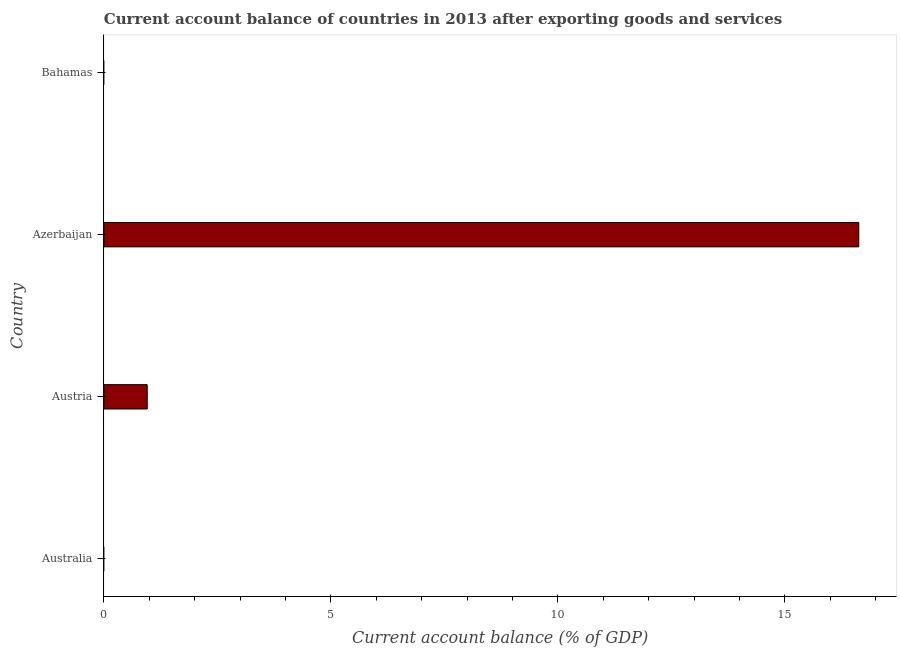What is the title of the graph?
Give a very brief answer. Current account balance of countries in 2013 after exporting goods and services. What is the label or title of the X-axis?
Make the answer very short. Current account balance (% of GDP). What is the label or title of the Y-axis?
Offer a terse response. Country. Across all countries, what is the maximum current account balance?
Your response must be concise. 16.63. In which country was the current account balance maximum?
Offer a terse response. Azerbaijan. What is the sum of the current account balance?
Offer a very short reply. 17.58. What is the difference between the current account balance in Austria and Azerbaijan?
Offer a very short reply. -15.67. What is the average current account balance per country?
Your answer should be very brief. 4.4. What is the median current account balance?
Offer a very short reply. 0.48. In how many countries, is the current account balance greater than 13 %?
Offer a terse response. 1. Is the current account balance in Austria less than that in Azerbaijan?
Keep it short and to the point. Yes. Is the difference between the current account balance in Austria and Azerbaijan greater than the difference between any two countries?
Provide a succinct answer. No. What is the difference between the highest and the lowest current account balance?
Your answer should be very brief. 16.63. In how many countries, is the current account balance greater than the average current account balance taken over all countries?
Provide a short and direct response. 1. How many bars are there?
Your response must be concise. 2. Are all the bars in the graph horizontal?
Provide a short and direct response. Yes. What is the difference between two consecutive major ticks on the X-axis?
Provide a succinct answer. 5. Are the values on the major ticks of X-axis written in scientific E-notation?
Provide a short and direct response. No. What is the Current account balance (% of GDP) of Australia?
Your response must be concise. 0. What is the Current account balance (% of GDP) in Austria?
Offer a terse response. 0.95. What is the Current account balance (% of GDP) of Azerbaijan?
Give a very brief answer. 16.63. What is the Current account balance (% of GDP) of Bahamas?
Your response must be concise. 0. What is the difference between the Current account balance (% of GDP) in Austria and Azerbaijan?
Provide a short and direct response. -15.67. What is the ratio of the Current account balance (% of GDP) in Austria to that in Azerbaijan?
Offer a very short reply. 0.06. 